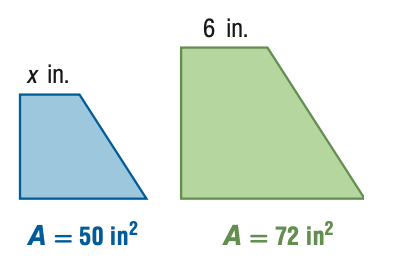Question: For the pair of similar figures, use the given areas to find x.
Choices:
A. 4.2
B. 5
C. 7.2
D. 8.6
Answer with the letter. Answer: B Question: For the pair of similar figures, use the given areas to find the scale factor of the blue to the green figure.
Choices:
A. \frac { 25 } { 36 }
B. \frac { 5 } { 6 }
C. \frac { 6 } { 5 }
D. \frac { 36 } { 25 }
Answer with the letter. Answer: B 